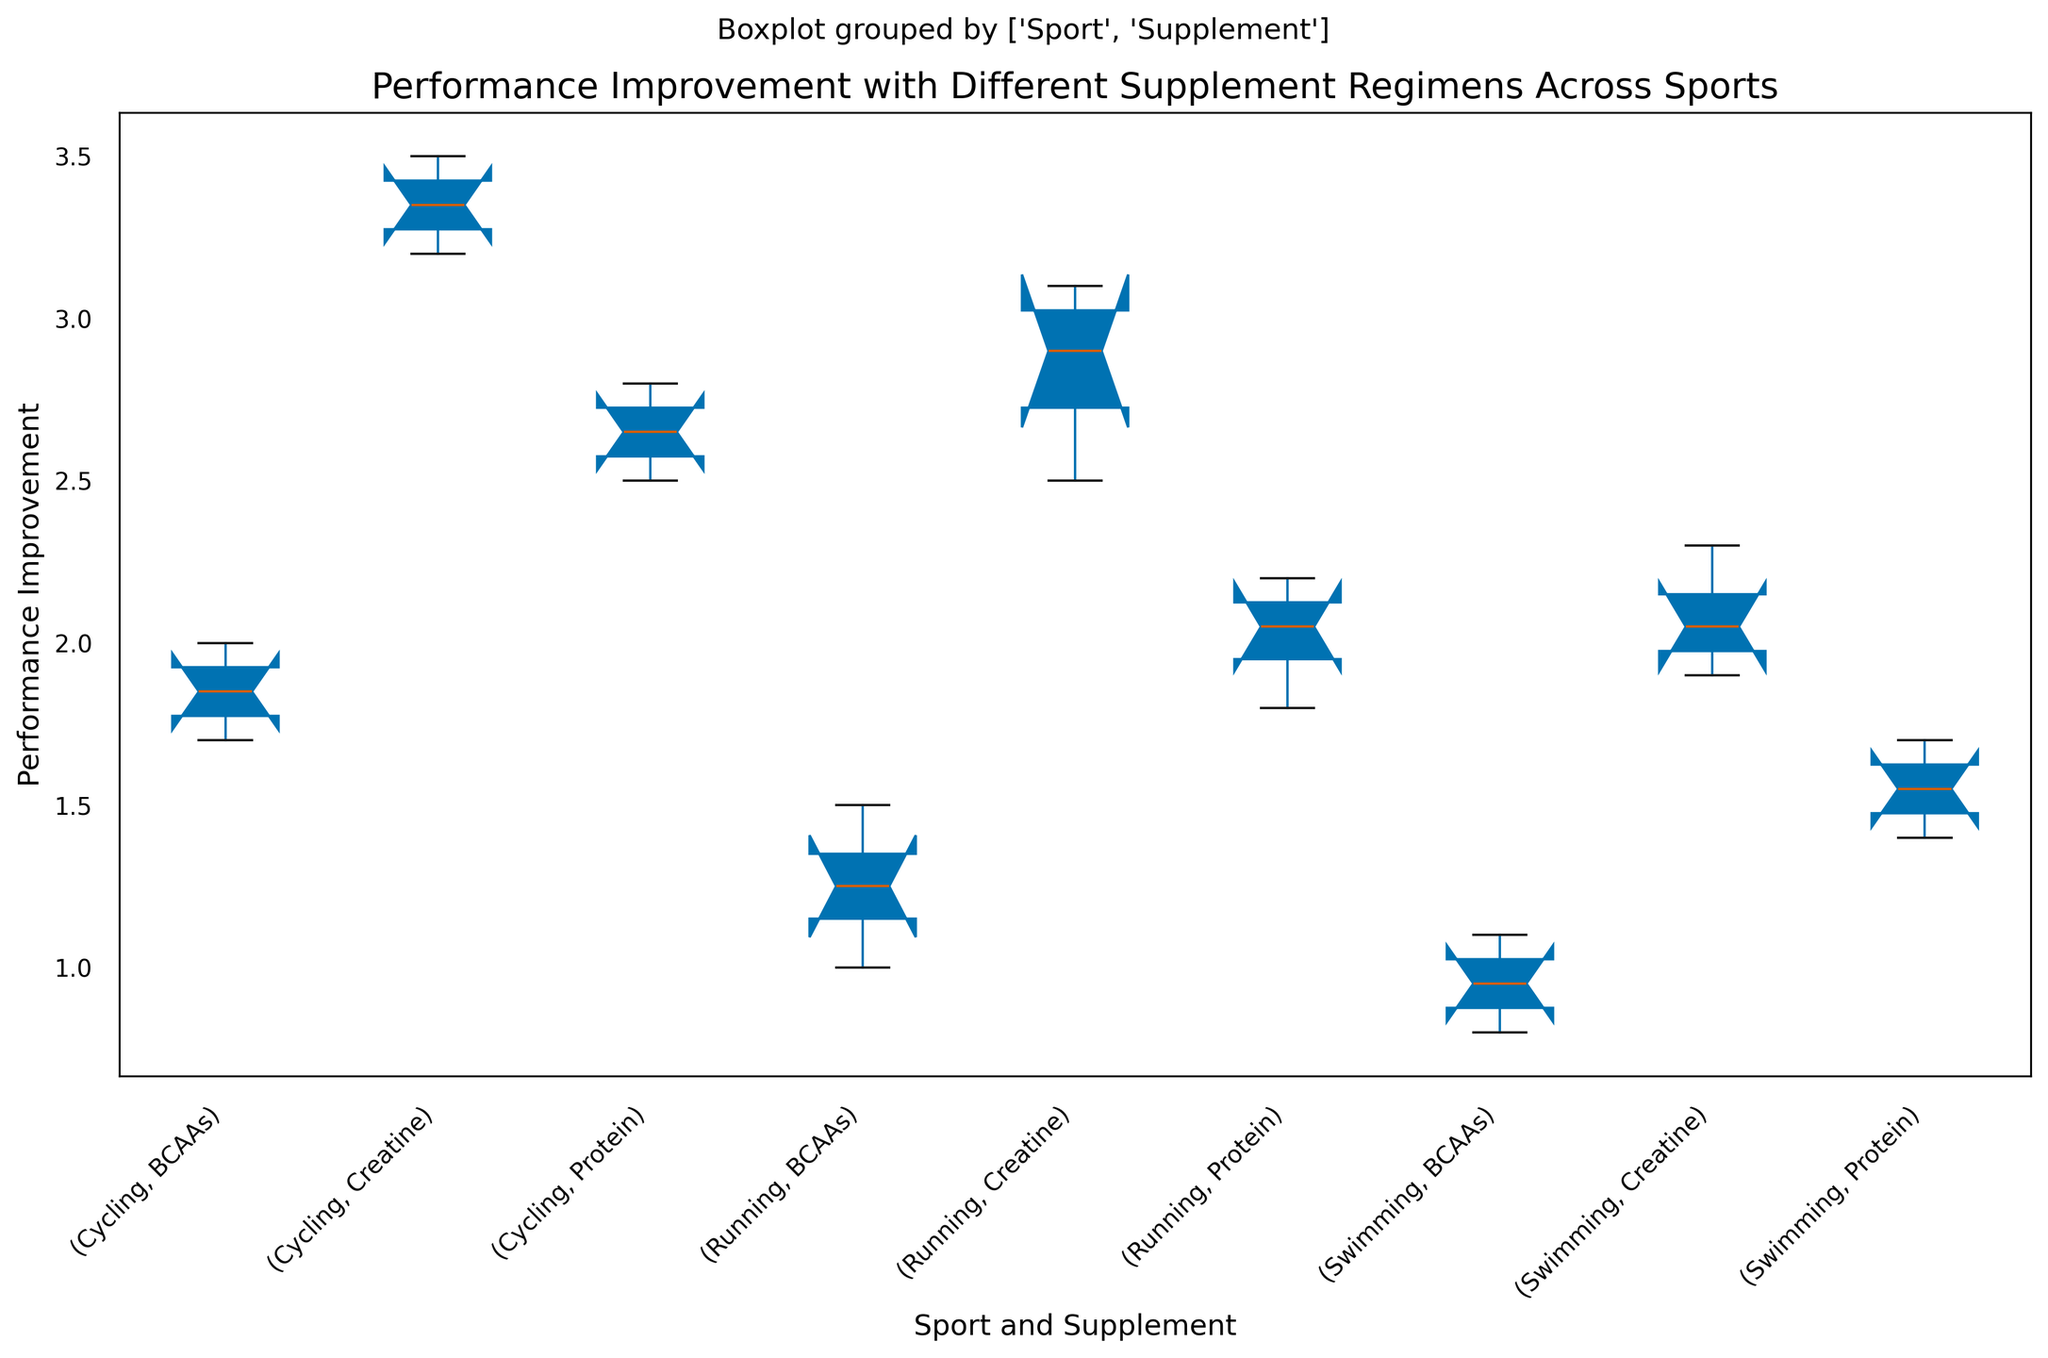Which sport and supplement combination shows the highest median performance improvement? Look at the center line inside each of the box plots. The box plot with the highest center line represents the highest median performance improvement.
Answer: Cycling with Creatine What is the range of performance improvement values for runners using BCAAs? Observe the bottom and top edges of the box plot (the hinges) for runners using BCAAs. They are the lower and upper quartiles, respectively. Additionally, include the whiskers which extend to the minimum and maximum values.
Answer: 1.0 to 1.5 Which supplement has the lowest median performance improvement for swimming? Find the center lines of the box plots for swimming and identify the one that is the lowest.
Answer: BCAAs How does the median performance improvement for running with Protein compare to running with Creatine? Identify the median (center line) of the box plots for running with Protein and Creatine, then compare their heights.
Answer: The median for running with Creatine is higher than with Protein What is the interquartile range (IQR) for performance improvement in cycling with Protein? Identify the bottom and top edges of the box (the 25th and 75th percentiles, respectively) for cycling with Protein. Subtract the value at the bottom edge from the value at the top edge to get the IQR.
Answer: 2.5 to 2.8, IQR = 0.3 Which sport and supplement combination has the smallest range of performance improvements? Examine the lengths of the whiskers (the lines extending from the boxes) for each combination to find the shortest.
Answer: Swimming with Creatine Between swimming and running, which sport shows a greater spread in performance improvements with Creatine? Compare the length of the whiskers and the height of the boxes of the two sports using Creatine.
Answer: Running Based on the box plots, which supplement shows the most variation in performance improvement for cycling? Look at the box plot with the widest spread (the maximum and minimum values indicated by the whiskers) among the supplements for cycling.
Answer: Creatine 